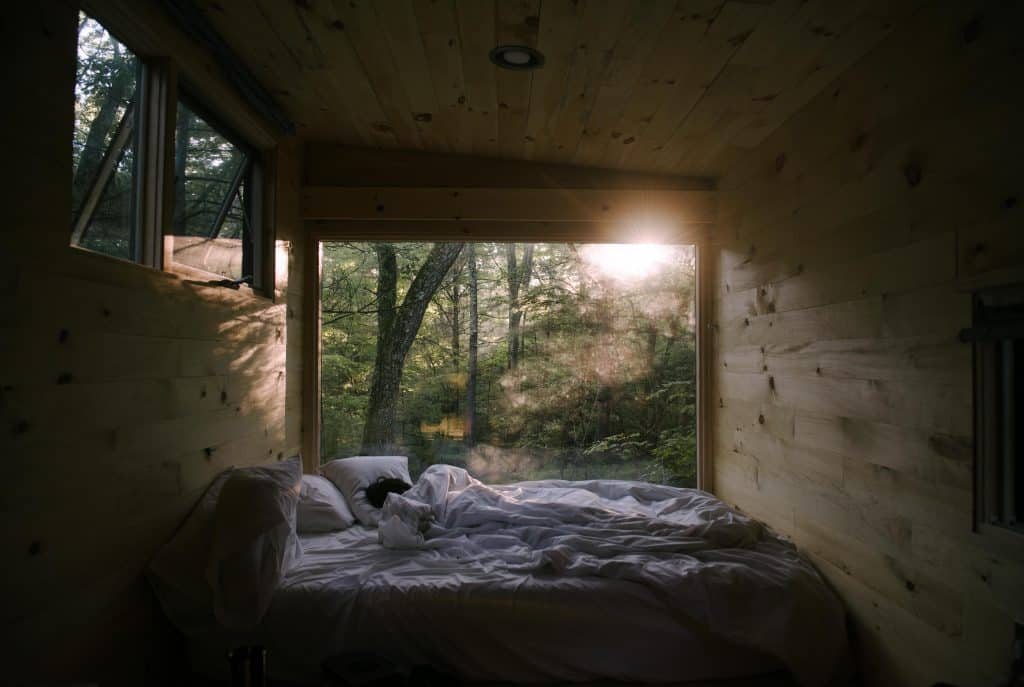What time of day does it appear to be and how does the light influence the atmosphere in the room? Based on the angle and quality of sunlight filtering through the forest and into the bedroom, it appears to be early morning. The soft, diffuse light creates a peaceful ambiance, gently stirring the room from the shadows of night. This dawning light can invigorate the start of the day with a sense of freshness and possibility. 